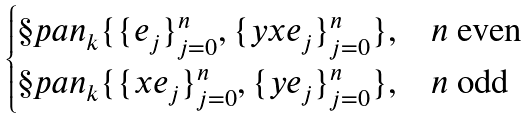<formula> <loc_0><loc_0><loc_500><loc_500>\begin{cases} \S p a n _ { k } \{ \{ e _ { j } \} _ { j = 0 } ^ { n } , \{ y x e _ { j } \} _ { j = 0 } ^ { n } \} , & n \text {\ even} \\ \S p a n _ { k } \{ \{ x e _ { j } \} _ { j = 0 } ^ { n } , \{ y e _ { j } \} _ { j = 0 } ^ { n } \} , & n \text {\ odd} \end{cases}</formula> 